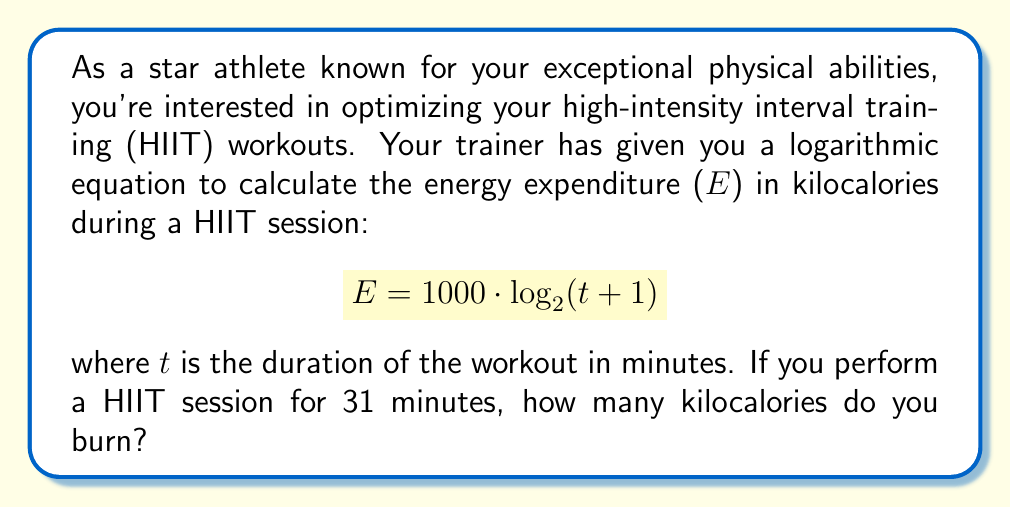Teach me how to tackle this problem. To solve this problem, we need to use the given logarithmic equation and substitute the known value for t. Let's break it down step-by-step:

1. The given equation is:
   $$E = 1000 \cdot \log_2(t + 1)$$

2. We know that t = 31 minutes, so let's substitute this value:
   $$E = 1000 \cdot \log_2(31 + 1)$$
   $$E = 1000 \cdot \log_2(32)$$

3. Now, we need to calculate $\log_2(32)$. We can simplify this by recognizing that 32 is a power of 2:
   $$32 = 2^5$$

4. Therefore, $\log_2(32) = 5$

5. Substituting this back into our equation:
   $$E = 1000 \cdot 5$$

6. Finally, we can calculate the result:
   $$E = 5000$$

Thus, during a 31-minute HIIT session, you would burn 5000 kilocalories according to this logarithmic model.
Answer: 5000 kilocalories 